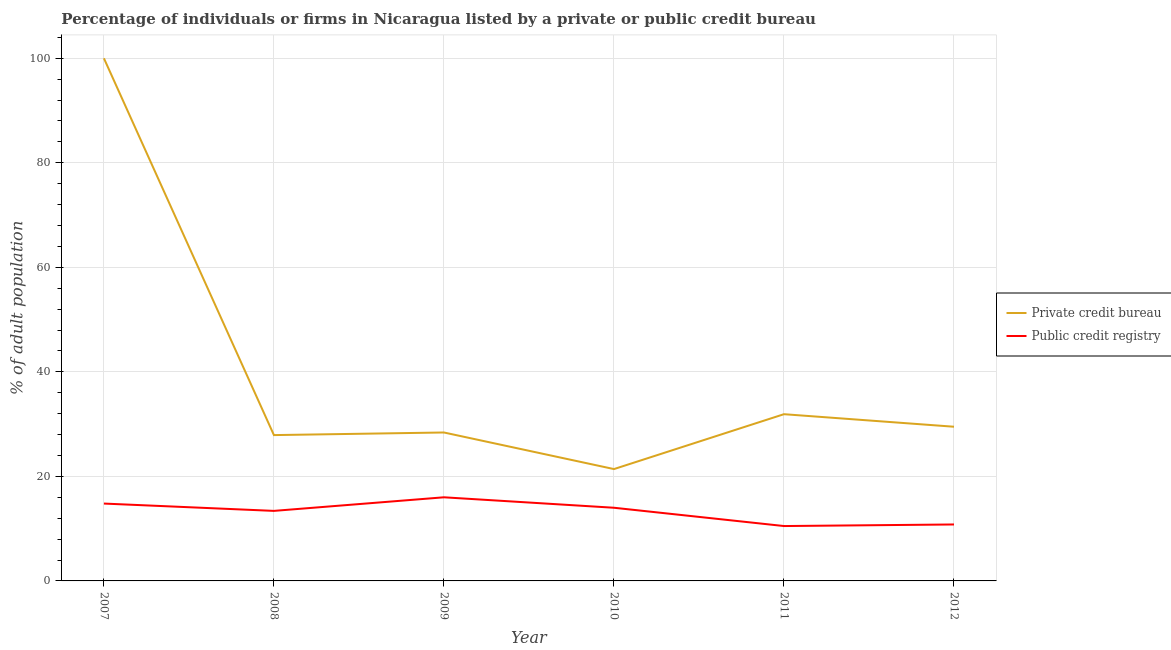Does the line corresponding to percentage of firms listed by public credit bureau intersect with the line corresponding to percentage of firms listed by private credit bureau?
Provide a short and direct response. No. Is the number of lines equal to the number of legend labels?
Keep it short and to the point. Yes. What is the percentage of firms listed by public credit bureau in 2011?
Your response must be concise. 10.5. Across all years, what is the minimum percentage of firms listed by private credit bureau?
Your answer should be compact. 21.4. In which year was the percentage of firms listed by private credit bureau maximum?
Give a very brief answer. 2007. In which year was the percentage of firms listed by public credit bureau minimum?
Offer a very short reply. 2011. What is the total percentage of firms listed by private credit bureau in the graph?
Ensure brevity in your answer.  239.1. What is the difference between the percentage of firms listed by private credit bureau in 2009 and that in 2012?
Offer a very short reply. -1.1. What is the difference between the percentage of firms listed by public credit bureau in 2009 and the percentage of firms listed by private credit bureau in 2008?
Keep it short and to the point. -11.9. What is the average percentage of firms listed by public credit bureau per year?
Provide a short and direct response. 13.25. In the year 2007, what is the difference between the percentage of firms listed by public credit bureau and percentage of firms listed by private credit bureau?
Provide a short and direct response. -85.2. In how many years, is the percentage of firms listed by public credit bureau greater than 44 %?
Provide a succinct answer. 0. What is the ratio of the percentage of firms listed by public credit bureau in 2008 to that in 2012?
Your answer should be compact. 1.24. What is the difference between the highest and the second highest percentage of firms listed by private credit bureau?
Offer a very short reply. 68.1. What is the difference between the highest and the lowest percentage of firms listed by public credit bureau?
Ensure brevity in your answer.  5.5. Is the sum of the percentage of firms listed by private credit bureau in 2007 and 2011 greater than the maximum percentage of firms listed by public credit bureau across all years?
Provide a succinct answer. Yes. Is the percentage of firms listed by public credit bureau strictly greater than the percentage of firms listed by private credit bureau over the years?
Ensure brevity in your answer.  No. How many lines are there?
Your response must be concise. 2. Does the graph contain any zero values?
Give a very brief answer. No. Where does the legend appear in the graph?
Make the answer very short. Center right. How are the legend labels stacked?
Make the answer very short. Vertical. What is the title of the graph?
Provide a succinct answer. Percentage of individuals or firms in Nicaragua listed by a private or public credit bureau. What is the label or title of the X-axis?
Your answer should be very brief. Year. What is the label or title of the Y-axis?
Provide a succinct answer. % of adult population. What is the % of adult population in Private credit bureau in 2008?
Provide a short and direct response. 27.9. What is the % of adult population in Public credit registry in 2008?
Your answer should be compact. 13.4. What is the % of adult population of Private credit bureau in 2009?
Ensure brevity in your answer.  28.4. What is the % of adult population in Private credit bureau in 2010?
Your answer should be very brief. 21.4. What is the % of adult population in Public credit registry in 2010?
Give a very brief answer. 14. What is the % of adult population of Private credit bureau in 2011?
Ensure brevity in your answer.  31.9. What is the % of adult population in Public credit registry in 2011?
Ensure brevity in your answer.  10.5. What is the % of adult population of Private credit bureau in 2012?
Provide a succinct answer. 29.5. What is the % of adult population in Public credit registry in 2012?
Provide a short and direct response. 10.8. Across all years, what is the maximum % of adult population in Private credit bureau?
Provide a short and direct response. 100. Across all years, what is the maximum % of adult population in Public credit registry?
Your answer should be compact. 16. Across all years, what is the minimum % of adult population of Private credit bureau?
Provide a short and direct response. 21.4. What is the total % of adult population of Private credit bureau in the graph?
Your answer should be very brief. 239.1. What is the total % of adult population of Public credit registry in the graph?
Offer a terse response. 79.5. What is the difference between the % of adult population in Private credit bureau in 2007 and that in 2008?
Provide a succinct answer. 72.1. What is the difference between the % of adult population of Public credit registry in 2007 and that in 2008?
Provide a short and direct response. 1.4. What is the difference between the % of adult population in Private credit bureau in 2007 and that in 2009?
Your answer should be very brief. 71.6. What is the difference between the % of adult population in Private credit bureau in 2007 and that in 2010?
Offer a very short reply. 78.6. What is the difference between the % of adult population of Public credit registry in 2007 and that in 2010?
Ensure brevity in your answer.  0.8. What is the difference between the % of adult population in Private credit bureau in 2007 and that in 2011?
Offer a very short reply. 68.1. What is the difference between the % of adult population of Public credit registry in 2007 and that in 2011?
Provide a succinct answer. 4.3. What is the difference between the % of adult population in Private credit bureau in 2007 and that in 2012?
Offer a terse response. 70.5. What is the difference between the % of adult population in Public credit registry in 2007 and that in 2012?
Your response must be concise. 4. What is the difference between the % of adult population of Private credit bureau in 2008 and that in 2009?
Ensure brevity in your answer.  -0.5. What is the difference between the % of adult population in Private credit bureau in 2008 and that in 2010?
Provide a short and direct response. 6.5. What is the difference between the % of adult population in Public credit registry in 2008 and that in 2010?
Ensure brevity in your answer.  -0.6. What is the difference between the % of adult population of Private credit bureau in 2008 and that in 2011?
Provide a succinct answer. -4. What is the difference between the % of adult population in Public credit registry in 2009 and that in 2010?
Your answer should be very brief. 2. What is the difference between the % of adult population of Private credit bureau in 2009 and that in 2012?
Offer a terse response. -1.1. What is the difference between the % of adult population of Private credit bureau in 2010 and that in 2012?
Your answer should be compact. -8.1. What is the difference between the % of adult population of Private credit bureau in 2011 and that in 2012?
Your answer should be very brief. 2.4. What is the difference between the % of adult population in Private credit bureau in 2007 and the % of adult population in Public credit registry in 2008?
Ensure brevity in your answer.  86.6. What is the difference between the % of adult population in Private credit bureau in 2007 and the % of adult population in Public credit registry in 2011?
Make the answer very short. 89.5. What is the difference between the % of adult population of Private credit bureau in 2007 and the % of adult population of Public credit registry in 2012?
Your response must be concise. 89.2. What is the difference between the % of adult population in Private credit bureau in 2008 and the % of adult population in Public credit registry in 2012?
Your answer should be very brief. 17.1. What is the difference between the % of adult population in Private credit bureau in 2009 and the % of adult population in Public credit registry in 2010?
Offer a very short reply. 14.4. What is the difference between the % of adult population of Private credit bureau in 2009 and the % of adult population of Public credit registry in 2011?
Your answer should be compact. 17.9. What is the difference between the % of adult population in Private credit bureau in 2009 and the % of adult population in Public credit registry in 2012?
Offer a very short reply. 17.6. What is the difference between the % of adult population of Private credit bureau in 2010 and the % of adult population of Public credit registry in 2011?
Your answer should be compact. 10.9. What is the difference between the % of adult population of Private credit bureau in 2010 and the % of adult population of Public credit registry in 2012?
Your response must be concise. 10.6. What is the difference between the % of adult population of Private credit bureau in 2011 and the % of adult population of Public credit registry in 2012?
Your response must be concise. 21.1. What is the average % of adult population in Private credit bureau per year?
Your answer should be very brief. 39.85. What is the average % of adult population of Public credit registry per year?
Provide a short and direct response. 13.25. In the year 2007, what is the difference between the % of adult population in Private credit bureau and % of adult population in Public credit registry?
Offer a very short reply. 85.2. In the year 2010, what is the difference between the % of adult population of Private credit bureau and % of adult population of Public credit registry?
Make the answer very short. 7.4. In the year 2011, what is the difference between the % of adult population of Private credit bureau and % of adult population of Public credit registry?
Offer a very short reply. 21.4. In the year 2012, what is the difference between the % of adult population of Private credit bureau and % of adult population of Public credit registry?
Offer a very short reply. 18.7. What is the ratio of the % of adult population of Private credit bureau in 2007 to that in 2008?
Your answer should be compact. 3.58. What is the ratio of the % of adult population in Public credit registry in 2007 to that in 2008?
Make the answer very short. 1.1. What is the ratio of the % of adult population of Private credit bureau in 2007 to that in 2009?
Provide a short and direct response. 3.52. What is the ratio of the % of adult population of Public credit registry in 2007 to that in 2009?
Provide a succinct answer. 0.93. What is the ratio of the % of adult population in Private credit bureau in 2007 to that in 2010?
Your answer should be very brief. 4.67. What is the ratio of the % of adult population of Public credit registry in 2007 to that in 2010?
Keep it short and to the point. 1.06. What is the ratio of the % of adult population of Private credit bureau in 2007 to that in 2011?
Offer a terse response. 3.13. What is the ratio of the % of adult population of Public credit registry in 2007 to that in 2011?
Keep it short and to the point. 1.41. What is the ratio of the % of adult population of Private credit bureau in 2007 to that in 2012?
Provide a short and direct response. 3.39. What is the ratio of the % of adult population in Public credit registry in 2007 to that in 2012?
Make the answer very short. 1.37. What is the ratio of the % of adult population in Private credit bureau in 2008 to that in 2009?
Offer a very short reply. 0.98. What is the ratio of the % of adult population of Public credit registry in 2008 to that in 2009?
Your response must be concise. 0.84. What is the ratio of the % of adult population of Private credit bureau in 2008 to that in 2010?
Provide a succinct answer. 1.3. What is the ratio of the % of adult population of Public credit registry in 2008 to that in 2010?
Offer a very short reply. 0.96. What is the ratio of the % of adult population of Private credit bureau in 2008 to that in 2011?
Your response must be concise. 0.87. What is the ratio of the % of adult population in Public credit registry in 2008 to that in 2011?
Offer a terse response. 1.28. What is the ratio of the % of adult population of Private credit bureau in 2008 to that in 2012?
Offer a terse response. 0.95. What is the ratio of the % of adult population in Public credit registry in 2008 to that in 2012?
Ensure brevity in your answer.  1.24. What is the ratio of the % of adult population in Private credit bureau in 2009 to that in 2010?
Offer a terse response. 1.33. What is the ratio of the % of adult population in Private credit bureau in 2009 to that in 2011?
Provide a succinct answer. 0.89. What is the ratio of the % of adult population in Public credit registry in 2009 to that in 2011?
Your answer should be very brief. 1.52. What is the ratio of the % of adult population in Private credit bureau in 2009 to that in 2012?
Provide a succinct answer. 0.96. What is the ratio of the % of adult population in Public credit registry in 2009 to that in 2012?
Give a very brief answer. 1.48. What is the ratio of the % of adult population of Private credit bureau in 2010 to that in 2011?
Ensure brevity in your answer.  0.67. What is the ratio of the % of adult population of Private credit bureau in 2010 to that in 2012?
Your response must be concise. 0.73. What is the ratio of the % of adult population of Public credit registry in 2010 to that in 2012?
Provide a short and direct response. 1.3. What is the ratio of the % of adult population of Private credit bureau in 2011 to that in 2012?
Give a very brief answer. 1.08. What is the ratio of the % of adult population in Public credit registry in 2011 to that in 2012?
Keep it short and to the point. 0.97. What is the difference between the highest and the second highest % of adult population of Private credit bureau?
Make the answer very short. 68.1. What is the difference between the highest and the second highest % of adult population in Public credit registry?
Offer a very short reply. 1.2. What is the difference between the highest and the lowest % of adult population in Private credit bureau?
Offer a terse response. 78.6. What is the difference between the highest and the lowest % of adult population in Public credit registry?
Provide a succinct answer. 5.5. 